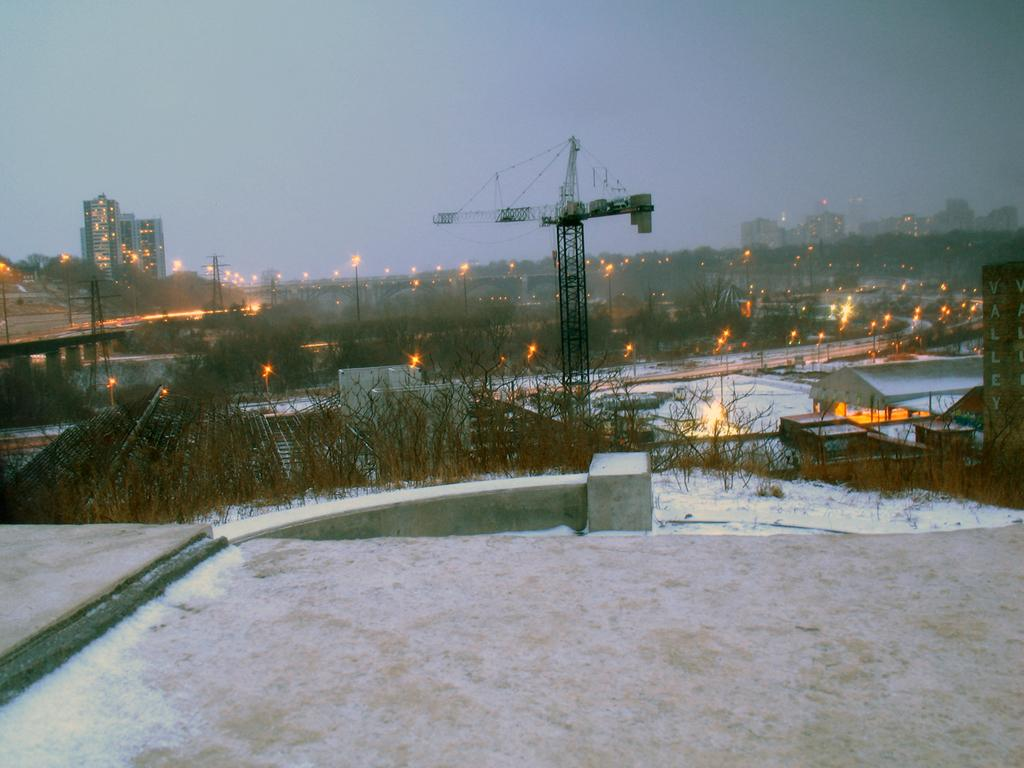What type of structures can be seen in the image? There are buildings in the image. What objects are present that emit light? There are lights in the image. What type of vertical structures can be seen in the image? There are poles and towers in the image. What type of infrastructure is present in the image? There are wires in the image. What type of vegetation can be seen in the image? There are dry trees in the image. What weather condition is depicted in the image? There is snow in the image. What is the color of the sky in the image? The sky is blue in color. Can you tell me where the loaf is located in the image? There is no loaf present in the image. What type of letter is being delivered in the image? There is no letter or delivery depicted in the image. 